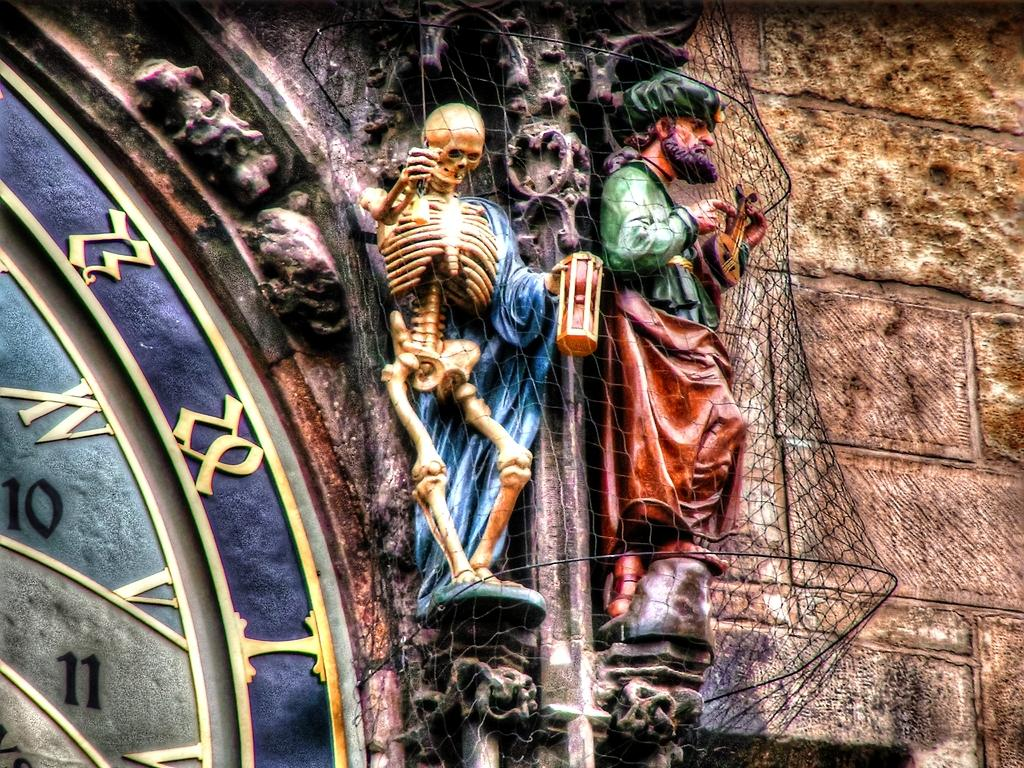What is the main structure in the picture? There is a tower in the picture. What feature does the tower have? The tower has a clock. Are there any other objects or figures near the clock? Yes, there are two statues beside the clock. Can you describe the people in the picture? There is a man in the picture. What other unusual figure is present in the image? There is a skeleton in the picture. What type of instrument is the man playing in the image? There is no instrument present in the image; the man is not playing any musical instrument. 